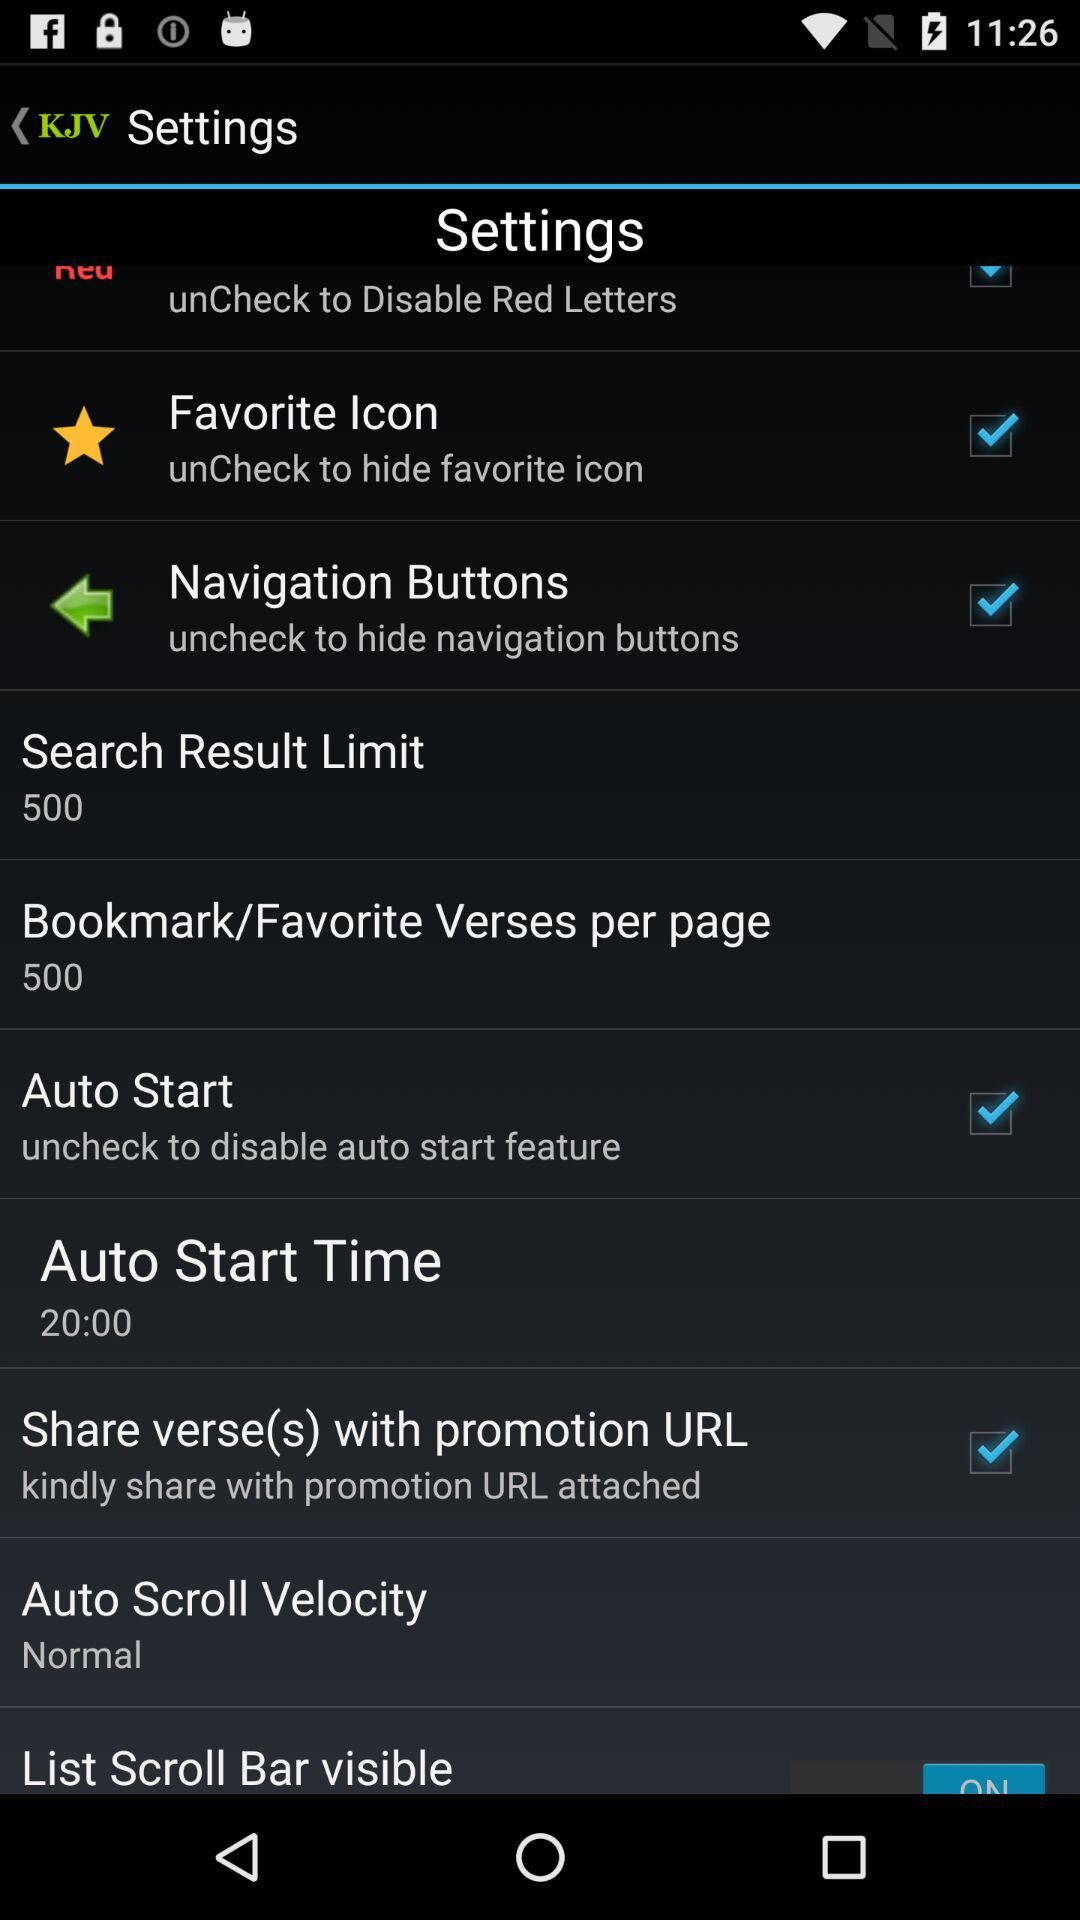What is the status of "Favorite Icon"? The status is "on". 